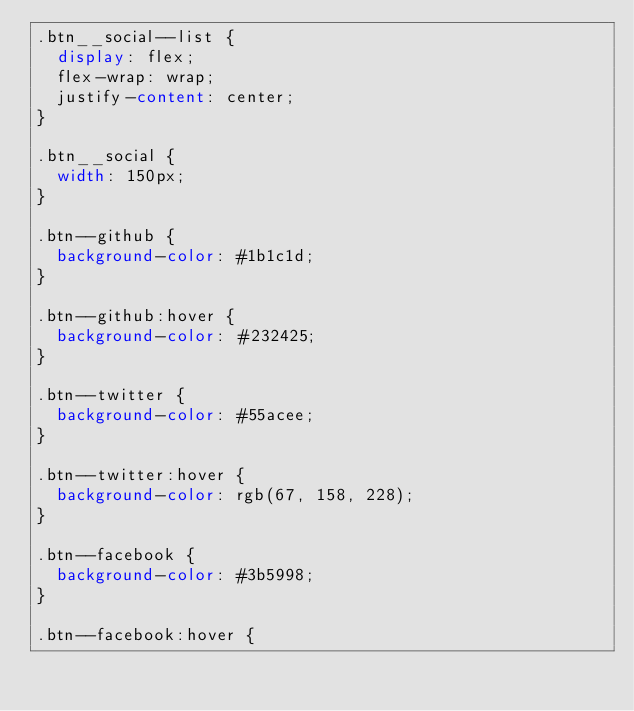<code> <loc_0><loc_0><loc_500><loc_500><_CSS_>.btn__social--list {
  display: flex;
  flex-wrap: wrap;
  justify-content: center;
}

.btn__social {
  width: 150px;
}

.btn--github {
  background-color: #1b1c1d;
}

.btn--github:hover {
  background-color: #232425;
}

.btn--twitter {
  background-color: #55acee;
}

.btn--twitter:hover {
  background-color: rgb(67, 158, 228);
}

.btn--facebook {
  background-color: #3b5998;
}

.btn--facebook:hover {</code> 